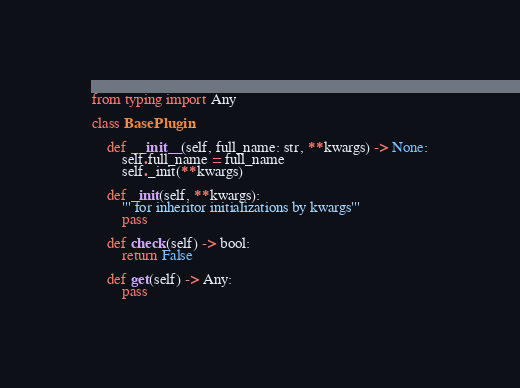<code> <loc_0><loc_0><loc_500><loc_500><_Python_>from typing import Any

class BasePlugin:

    def __init__(self, full_name: str, **kwargs) -> None:
        self.full_name = full_name
        self._init(**kwargs)

    def _init(self, **kwargs):
        ''' for inheritor initializations by kwargs'''
        pass

    def check(self) -> bool:
        return False

    def get(self) -> Any:
        pass

</code> 